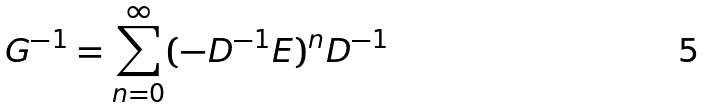Convert formula to latex. <formula><loc_0><loc_0><loc_500><loc_500>{ G } ^ { - 1 } = \sum _ { n = 0 } ^ { \infty } ( - { D } ^ { - 1 } { E } ) ^ { n } { D } ^ { - 1 }</formula> 